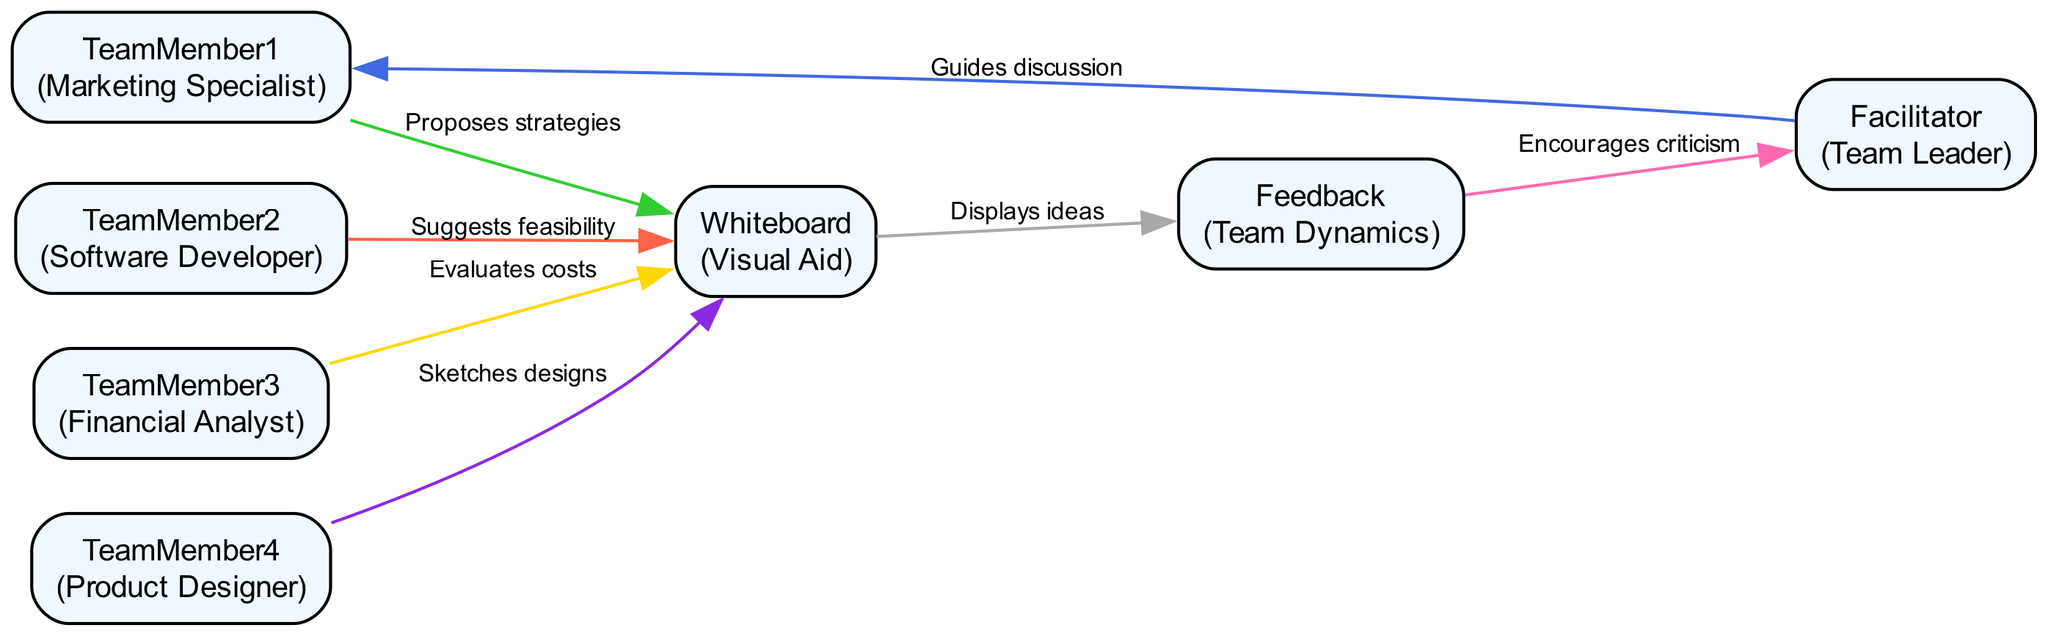What is the role of TeamMember1? TeamMember1 is designated as the "Marketing Specialist," whose primary action is to propose innovative marketing strategies during the brainstorming session.
Answer: Marketing Specialist How many edges are in the diagram? The diagram consists of a total of 7 edges connecting various team members, elements, and feedback mechanisms. Each edge represents a different interaction or flow of information.
Answer: 7 Who guides the discussion? The "Facilitator," who holds the role of Team Leader, is responsible for guiding the discussion and maintaining focus among team members during the brainstorming session.
Answer: Facilitator What does TeamMember3 evaluate? TeamMember3, the Financial Analyst, evaluates cost implications and funding options relevant to the ideas being brainstormed.
Answer: Cost implications and funding options What is the first action taken after the facilitator guides the discussion? After guidance from the Facilitator, TeamMember1 proposes innovative marketing strategies, marking the beginning of the active brainstorming process.
Answer: Proposes innovative marketing strategies What does the Whiteboard display? The Whiteboard serves as a visual aid that displays the ideas and notes generated during the brainstorming session, allowing team members to visualize contributions collectively.
Answer: Ideas and notes Which team member suggests technical feasibility? TeamMember2, the Software Developer, suggests the technical feasibility of ideas presented during the brainstorming session, ensuring practical implementation is considered.
Answer: Software Developer What action follows after feedback is given? After receiving feedback, the Facilitator is informed and encouraged to facilitate further discussion based on the constructive criticism provided.
Answer: Encourages criticism How do the team members interact with the whiteboard? TeamMembers propose strategies, suggest feasibility, evaluate costs, and sketch designs, all of which are communicated through the whiteboard, making it central to their collective interaction.
Answer: Proposes strategies, suggests feasibility, evaluates costs, sketches designs 